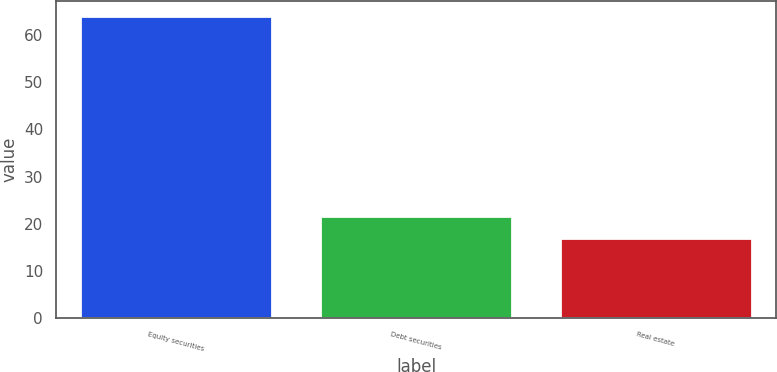Convert chart to OTSL. <chart><loc_0><loc_0><loc_500><loc_500><bar_chart><fcel>Equity securities<fcel>Debt securities<fcel>Real estate<nl><fcel>64<fcel>21.7<fcel>17<nl></chart> 